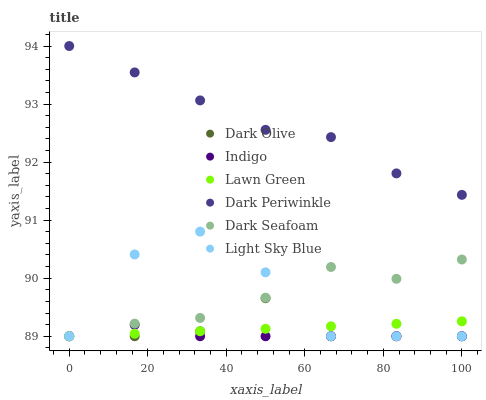Does Indigo have the minimum area under the curve?
Answer yes or no. Yes. Does Dark Periwinkle have the maximum area under the curve?
Answer yes or no. Yes. Does Dark Olive have the minimum area under the curve?
Answer yes or no. No. Does Dark Olive have the maximum area under the curve?
Answer yes or no. No. Is Lawn Green the smoothest?
Answer yes or no. Yes. Is Light Sky Blue the roughest?
Answer yes or no. Yes. Is Indigo the smoothest?
Answer yes or no. No. Is Indigo the roughest?
Answer yes or no. No. Does Lawn Green have the lowest value?
Answer yes or no. Yes. Does Dark Periwinkle have the lowest value?
Answer yes or no. No. Does Dark Periwinkle have the highest value?
Answer yes or no. Yes. Does Dark Olive have the highest value?
Answer yes or no. No. Is Dark Seafoam less than Dark Periwinkle?
Answer yes or no. Yes. Is Dark Periwinkle greater than Dark Olive?
Answer yes or no. Yes. Does Dark Olive intersect Dark Seafoam?
Answer yes or no. Yes. Is Dark Olive less than Dark Seafoam?
Answer yes or no. No. Is Dark Olive greater than Dark Seafoam?
Answer yes or no. No. Does Dark Seafoam intersect Dark Periwinkle?
Answer yes or no. No. 